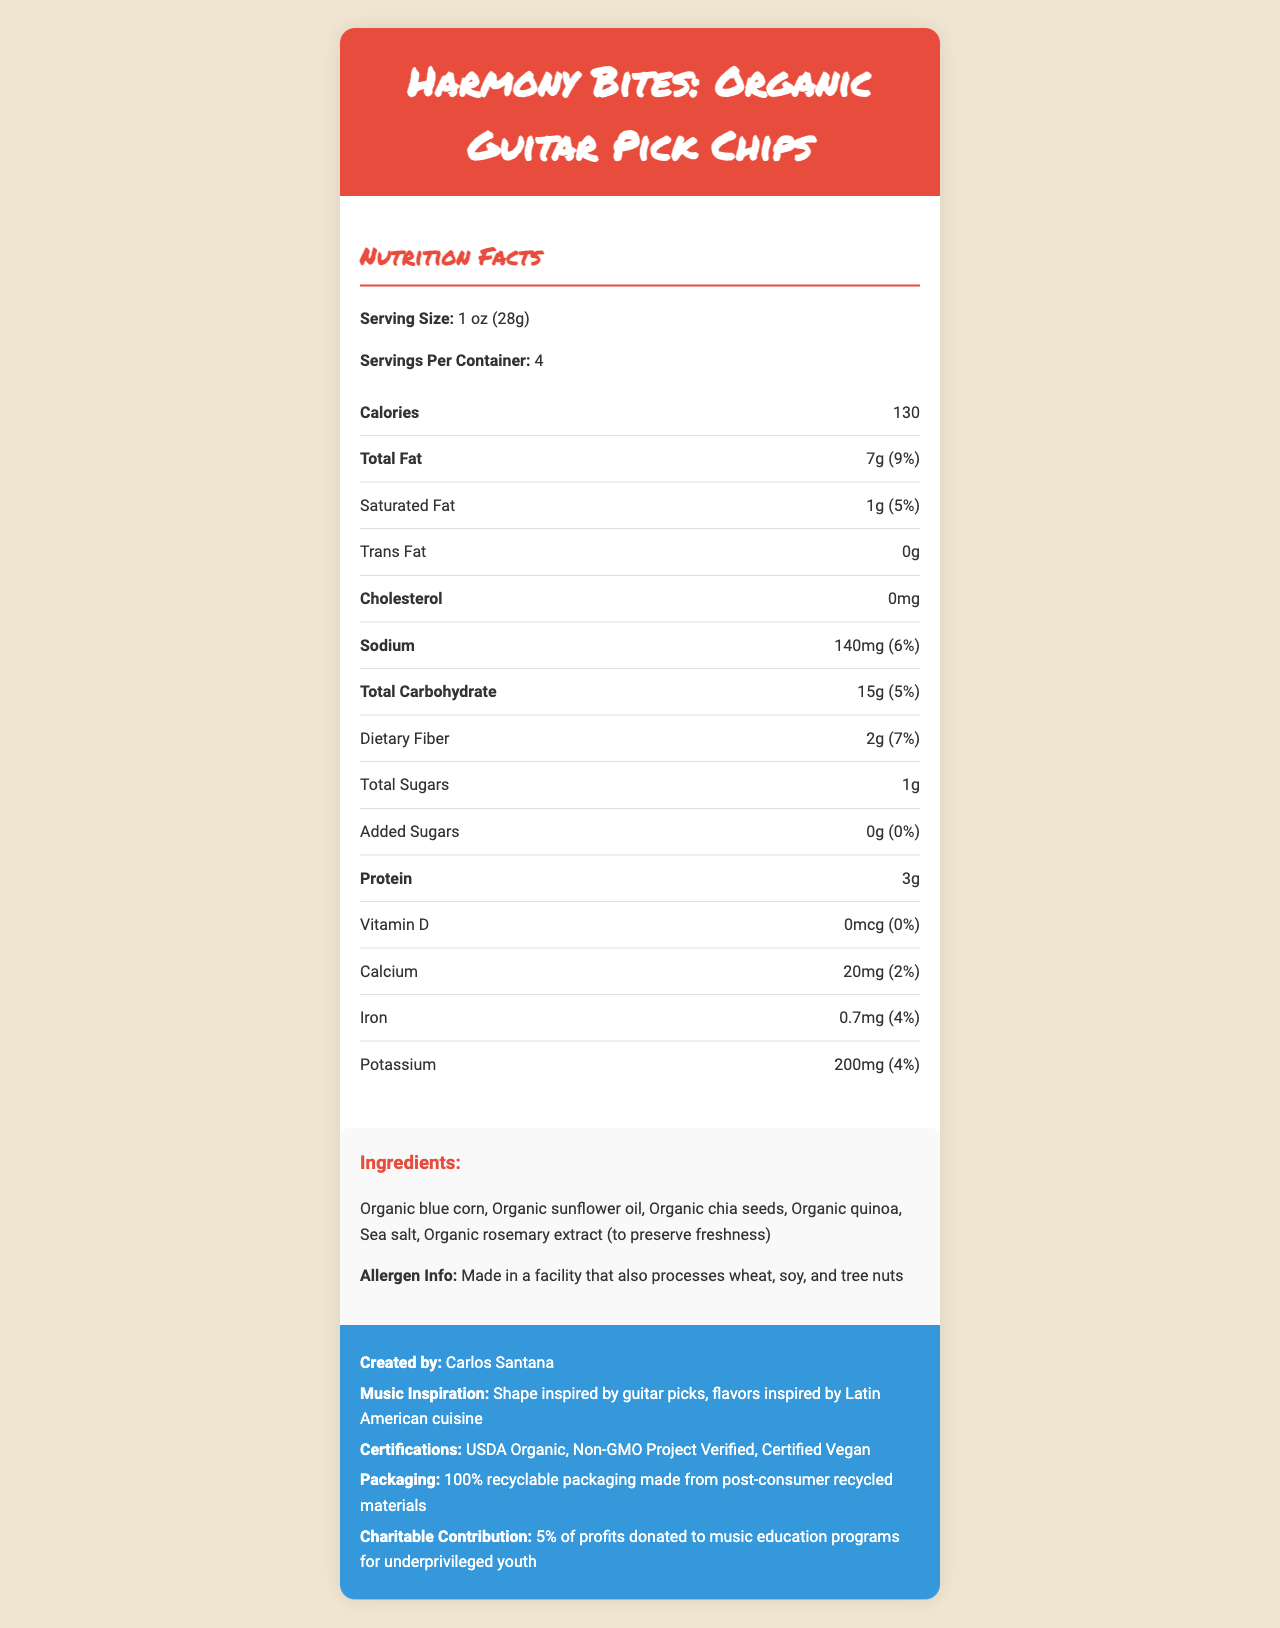what is the serving size of the Harmony Bites: Organic Guitar Pick Chips? The serving size is mentioned directly under the "Nutrition Facts" section as "Serving Size: 1 oz (28g)".
Answer: 1 oz (28g) how many calories are there per serving? The calories per serving are listed in the "Nutrition Facts" section as "Calories 130".
Answer: 130 how many servings are there in each container? The number of servings per container is given under the "Nutrition Facts" section as "Servings Per Container: 4".
Answer: 4 how much total fat is there in one serving and what percentage of the daily value is this? The total fat content per serving is provided in the "Nutrition Facts" section as "Total Fat 7g (9%)".
Answer: 7g (9%) what type of oil is used in the ingredients? The ingredients list in the document includes "Organic sunflower oil".
Answer: Organic sunflower oil who is the musician that created Harmony Bites? The musician creator is listed under "extra-info" as "Created by: Carlos Santana".
Answer: Carlos Santana which vitamin has 0% of the daily value in Harmony Bites? A. Vitamin A B. Vitamin C C. Vitamin D D. Vitamin E The "Nutrition Facts" section shows that "Vitamin D" has "0mcg (0%)".
Answer: C. Vitamin D how much sodium is in one serving? The sodium content per serving is listed under the "Nutrition Facts" section as "Sodium 140mg (6%)".
Answer: 140mg how much protein is there in one serving? The protein content per serving is given under the "Nutrition Facts" section as "Protein 3g".
Answer: 3g does Harmony Bites contain any trans fat? The "Nutrition Facts" section shows "Trans Fat 0g", indicating no trans fat.
Answer: No describe the main idea of the document. The document is a comprehensive overview of the nutritional content, ingredients, certifications, and other important attributes of the product "Harmony Bites," emphasizing its organic, vegan, and eco-friendly nature, as well as its inspiration from Latin American cuisine and contributions to music education.
Answer: The document provides detailed nutrition facts for "Harmony Bites: Organic Guitar Pick Chips," created by Carlos Santana. It includes nutritional information like calories, fats, and vitamins, ingredients, allergen info, certifications, packaging, and charitable contributions. are the Harmony Bites certified organic? The "Certifications" section in the extra-info lists "USDA Organic".
Answer: Yes how much dietary fiber is in one serving and what is its daily value percentage? The dietary fiber content and its daily value are listed under the "Nutrition Facts" section as "Dietary Fiber 2g (7%)".
Answer: 2g (7%) can the number of servings be determined by looking at the document? The number of servings per container is given as "Servings Per Container: 4".
Answer: Yes how are the Harmony Bites packaged? The packaging details are given in the extra-info section as "Packaging: 100% recyclable packaging made from post-consumer recycled materials."
Answer: The packaging is 100% recyclable and made from post-consumer recycled materials. where is the vitamin A content listed? The document does not contain information about Vitamin A content; therefore, details regarding Vitamin A cannot be determined from the provided visual information.
Answer: Not enough information what percentage of the profits is donated to music education programs? The charitable contribution is mentioned in the extra-info section as "5% of profits donated to music education programs for underprivileged youth".
Answer: 5% 